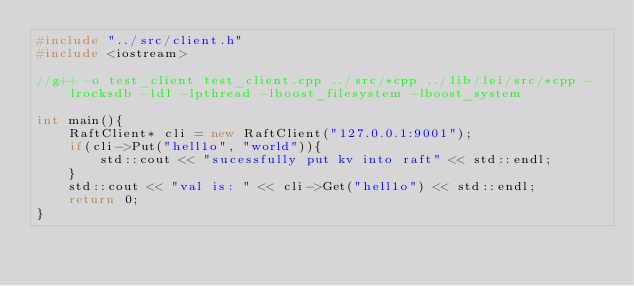<code> <loc_0><loc_0><loc_500><loc_500><_C++_>#include "../src/client.h"
#include <iostream>

//g++ -o test_client test_client.cpp ../src/*cpp ../lib/lei/src/*cpp -lrocksdb -ldl -lpthread -lboost_filesystem -lboost_system

int main(){
    RaftClient* cli = new RaftClient("127.0.0.1:9001");
    if(cli->Put("hell1o", "world")){
        std::cout << "sucessfully put kv into raft" << std::endl;
    }
    std::cout << "val is: " << cli->Get("hell1o") << std::endl;
    return 0;
}</code> 